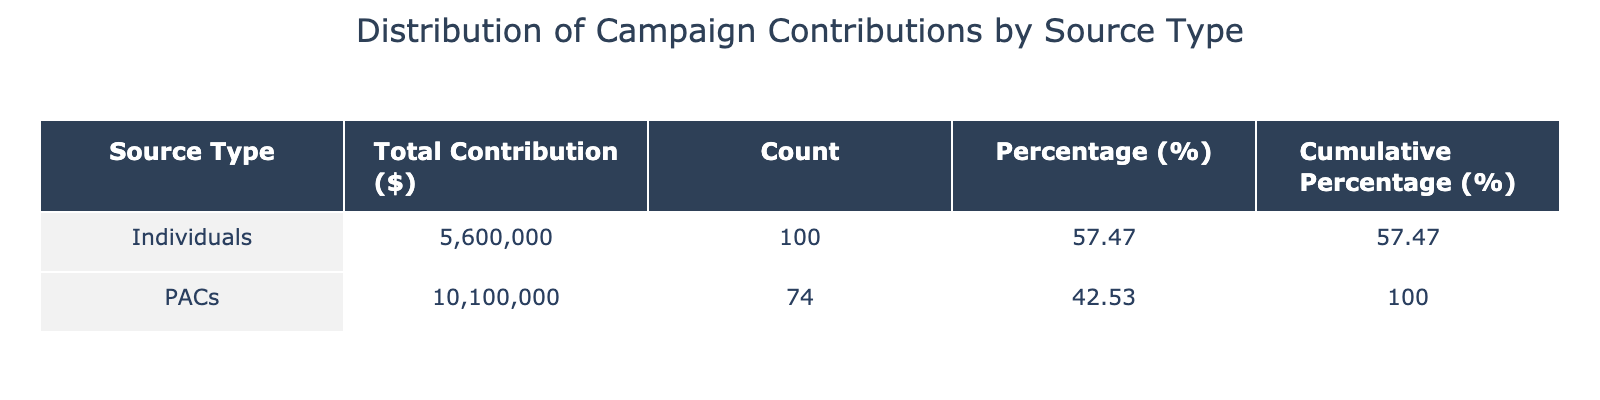What is the total contribution amount from individuals? To find this, I sum the "Campaign Contribution Amount (in USD)" for the rows where "Source Type" is "Individuals". The amounts are 1500000, 1000000, 1200000, 800000, and 1100000. When added together, they equal 1500000 + 1000000 + 1200000 + 800000 + 1100000 = 6,300,000.
Answer: 6300000 What percentage of total contributions comes from PACs? To determine the percentage, I first need to find the total contribution from PACs, which is 2000000 + 2500000 + 1800000 + 1600000 + 2200000 = 11100000. Next, I find the total contributions from both individuals and PACs, which is 6300000 + 11100000 = 17400000. The percentage from PACs is then (11100000 / 17400000) * 100, which is approximately 63.79%.
Answer: 63.79 True or False: Individuals contributed more than PACs in total. I calculated the total contributions: individuals contributed 6300000, while PACs contributed 11100000. Since 6300000 is less than 11100000, the statement is false.
Answer: False What is the cumulative percentage of contributions from individuals? The cumulative percentage for individuals can be found by looking at the table. The total count for individuals is 30 + 20 + 10 + 18 + 22 = 110. The percentage of total contributions for individuals is (110 / 250) * 100 = 44%. The cumulative percentage for individuals would be 44% for individuals only, since we are not accumulating any PAC percentage here.
Answer: 44 How many more contributions were made by individuals compared to PACs? First, I find the total counts for each group: individuals have a total count of 30 + 20 + 10 + 18 + 22 = 110, while PACs have a total count of 25 + 15 + 12 + 14 + 8 = 74. To find the difference, I subtract PACs from individuals: 110 - 74 = 36.
Answer: 36 